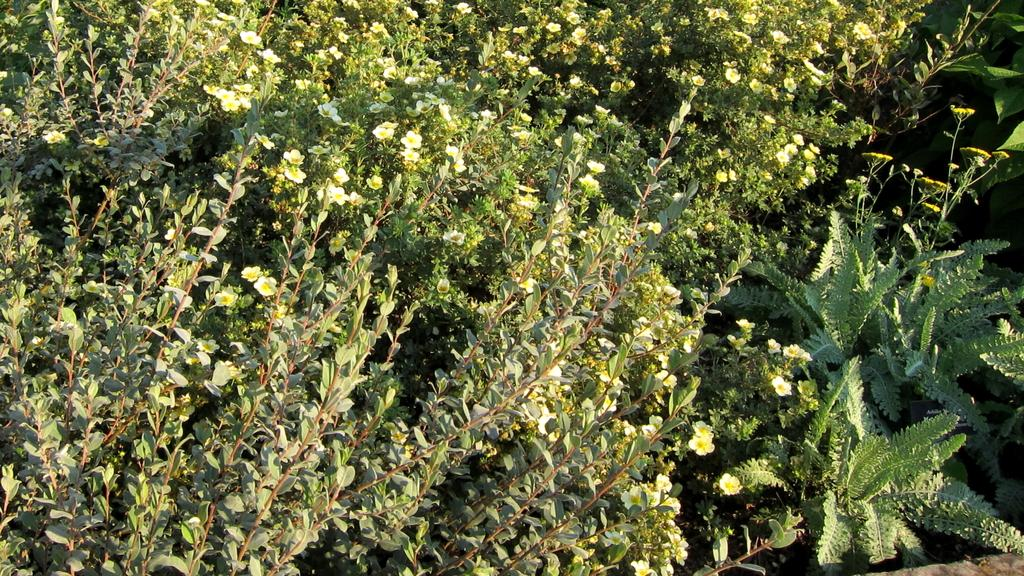What type of living organisms can be seen in the image? Plants can be seen in the image. Are there any specific features of the plants in the image? Some of the plants have flowers. What color are the flowers on the plants? The flowers are white in color. What type of work is the spade doing in the image? There is no spade present in the image, so it cannot be doing any work. 